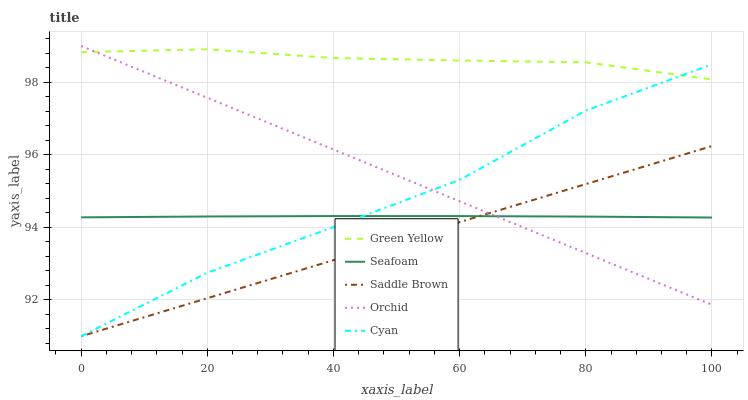Does Saddle Brown have the minimum area under the curve?
Answer yes or no. Yes. Does Green Yellow have the maximum area under the curve?
Answer yes or no. Yes. Does Cyan have the minimum area under the curve?
Answer yes or no. No. Does Cyan have the maximum area under the curve?
Answer yes or no. No. Is Saddle Brown the smoothest?
Answer yes or no. Yes. Is Cyan the roughest?
Answer yes or no. Yes. Is Green Yellow the smoothest?
Answer yes or no. No. Is Green Yellow the roughest?
Answer yes or no. No. Does Cyan have the lowest value?
Answer yes or no. Yes. Does Green Yellow have the lowest value?
Answer yes or no. No. Does Orchid have the highest value?
Answer yes or no. Yes. Does Cyan have the highest value?
Answer yes or no. No. Is Saddle Brown less than Green Yellow?
Answer yes or no. Yes. Is Green Yellow greater than Seafoam?
Answer yes or no. Yes. Does Cyan intersect Orchid?
Answer yes or no. Yes. Is Cyan less than Orchid?
Answer yes or no. No. Is Cyan greater than Orchid?
Answer yes or no. No. Does Saddle Brown intersect Green Yellow?
Answer yes or no. No. 